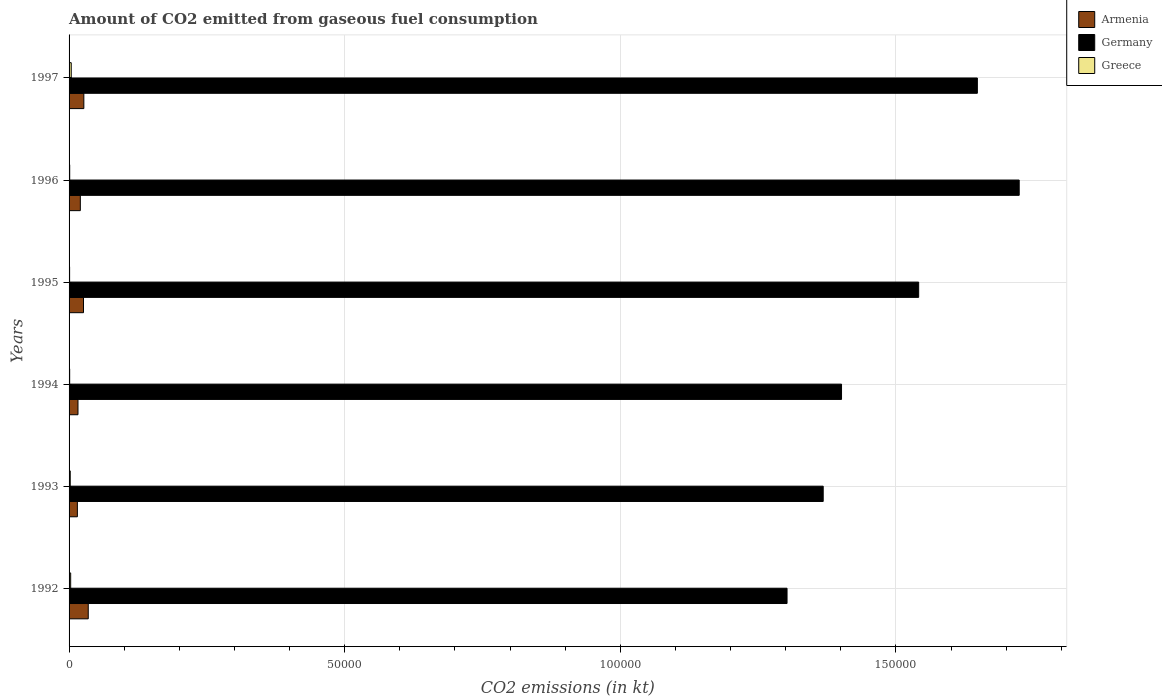How many different coloured bars are there?
Make the answer very short. 3. How many bars are there on the 3rd tick from the bottom?
Provide a succinct answer. 3. What is the label of the 4th group of bars from the top?
Keep it short and to the point. 1994. In how many cases, is the number of bars for a given year not equal to the number of legend labels?
Your answer should be very brief. 0. What is the amount of CO2 emitted in Germany in 1997?
Offer a very short reply. 1.65e+05. Across all years, what is the maximum amount of CO2 emitted in Greece?
Provide a short and direct response. 392.37. Across all years, what is the minimum amount of CO2 emitted in Greece?
Provide a short and direct response. 99.01. What is the total amount of CO2 emitted in Greece in the graph?
Make the answer very short. 1217.44. What is the difference between the amount of CO2 emitted in Greece in 1992 and that in 1996?
Your answer should be very brief. 176.02. What is the difference between the amount of CO2 emitted in Armenia in 1996 and the amount of CO2 emitted in Germany in 1995?
Keep it short and to the point. -1.52e+05. What is the average amount of CO2 emitted in Greece per year?
Offer a terse response. 202.91. In the year 1996, what is the difference between the amount of CO2 emitted in Armenia and amount of CO2 emitted in Greece?
Keep it short and to the point. 1928.84. What is the ratio of the amount of CO2 emitted in Armenia in 1992 to that in 1995?
Your response must be concise. 1.33. Is the amount of CO2 emitted in Armenia in 1993 less than that in 1996?
Your response must be concise. Yes. What is the difference between the highest and the second highest amount of CO2 emitted in Armenia?
Provide a succinct answer. 799.41. What is the difference between the highest and the lowest amount of CO2 emitted in Germany?
Your answer should be very brief. 4.21e+04. In how many years, is the amount of CO2 emitted in Greece greater than the average amount of CO2 emitted in Greece taken over all years?
Your answer should be compact. 3. Is the sum of the amount of CO2 emitted in Greece in 1995 and 1996 greater than the maximum amount of CO2 emitted in Armenia across all years?
Give a very brief answer. No. What does the 2nd bar from the bottom in 1992 represents?
Provide a short and direct response. Germany. Are all the bars in the graph horizontal?
Make the answer very short. Yes. How many years are there in the graph?
Keep it short and to the point. 6. Are the values on the major ticks of X-axis written in scientific E-notation?
Give a very brief answer. No. Where does the legend appear in the graph?
Offer a very short reply. Top right. How many legend labels are there?
Ensure brevity in your answer.  3. What is the title of the graph?
Make the answer very short. Amount of CO2 emitted from gaseous fuel consumption. Does "Nigeria" appear as one of the legend labels in the graph?
Provide a succinct answer. No. What is the label or title of the X-axis?
Ensure brevity in your answer.  CO2 emissions (in kt). What is the label or title of the Y-axis?
Keep it short and to the point. Years. What is the CO2 emissions (in kt) of Armenia in 1992?
Offer a terse response. 3479.98. What is the CO2 emissions (in kt) of Germany in 1992?
Keep it short and to the point. 1.30e+05. What is the CO2 emissions (in kt) of Greece in 1992?
Give a very brief answer. 289.69. What is the CO2 emissions (in kt) of Armenia in 1993?
Provide a short and direct response. 1507.14. What is the CO2 emissions (in kt) in Germany in 1993?
Offer a terse response. 1.37e+05. What is the CO2 emissions (in kt) of Greece in 1993?
Your response must be concise. 212.69. What is the CO2 emissions (in kt) of Armenia in 1994?
Offer a very short reply. 1617.15. What is the CO2 emissions (in kt) of Germany in 1994?
Give a very brief answer. 1.40e+05. What is the CO2 emissions (in kt) of Greece in 1994?
Your answer should be very brief. 110.01. What is the CO2 emissions (in kt) of Armenia in 1995?
Keep it short and to the point. 2618.24. What is the CO2 emissions (in kt) of Germany in 1995?
Your answer should be very brief. 1.54e+05. What is the CO2 emissions (in kt) of Greece in 1995?
Keep it short and to the point. 99.01. What is the CO2 emissions (in kt) in Armenia in 1996?
Offer a terse response. 2042.52. What is the CO2 emissions (in kt) of Germany in 1996?
Offer a terse response. 1.72e+05. What is the CO2 emissions (in kt) in Greece in 1996?
Offer a terse response. 113.68. What is the CO2 emissions (in kt) of Armenia in 1997?
Offer a terse response. 2680.58. What is the CO2 emissions (in kt) of Germany in 1997?
Give a very brief answer. 1.65e+05. What is the CO2 emissions (in kt) of Greece in 1997?
Provide a succinct answer. 392.37. Across all years, what is the maximum CO2 emissions (in kt) in Armenia?
Provide a short and direct response. 3479.98. Across all years, what is the maximum CO2 emissions (in kt) in Germany?
Offer a terse response. 1.72e+05. Across all years, what is the maximum CO2 emissions (in kt) of Greece?
Ensure brevity in your answer.  392.37. Across all years, what is the minimum CO2 emissions (in kt) of Armenia?
Give a very brief answer. 1507.14. Across all years, what is the minimum CO2 emissions (in kt) of Germany?
Provide a short and direct response. 1.30e+05. Across all years, what is the minimum CO2 emissions (in kt) of Greece?
Give a very brief answer. 99.01. What is the total CO2 emissions (in kt) of Armenia in the graph?
Make the answer very short. 1.39e+04. What is the total CO2 emissions (in kt) of Germany in the graph?
Your response must be concise. 8.99e+05. What is the total CO2 emissions (in kt) in Greece in the graph?
Your answer should be compact. 1217.44. What is the difference between the CO2 emissions (in kt) of Armenia in 1992 and that in 1993?
Ensure brevity in your answer.  1972.85. What is the difference between the CO2 emissions (in kt) of Germany in 1992 and that in 1993?
Make the answer very short. -6560.26. What is the difference between the CO2 emissions (in kt) in Greece in 1992 and that in 1993?
Keep it short and to the point. 77.01. What is the difference between the CO2 emissions (in kt) in Armenia in 1992 and that in 1994?
Keep it short and to the point. 1862.84. What is the difference between the CO2 emissions (in kt) in Germany in 1992 and that in 1994?
Make the answer very short. -9886.23. What is the difference between the CO2 emissions (in kt) of Greece in 1992 and that in 1994?
Provide a short and direct response. 179.68. What is the difference between the CO2 emissions (in kt) of Armenia in 1992 and that in 1995?
Your answer should be compact. 861.75. What is the difference between the CO2 emissions (in kt) of Germany in 1992 and that in 1995?
Keep it short and to the point. -2.39e+04. What is the difference between the CO2 emissions (in kt) of Greece in 1992 and that in 1995?
Ensure brevity in your answer.  190.68. What is the difference between the CO2 emissions (in kt) in Armenia in 1992 and that in 1996?
Offer a terse response. 1437.46. What is the difference between the CO2 emissions (in kt) of Germany in 1992 and that in 1996?
Your answer should be very brief. -4.21e+04. What is the difference between the CO2 emissions (in kt) of Greece in 1992 and that in 1996?
Offer a very short reply. 176.02. What is the difference between the CO2 emissions (in kt) in Armenia in 1992 and that in 1997?
Make the answer very short. 799.41. What is the difference between the CO2 emissions (in kt) in Germany in 1992 and that in 1997?
Keep it short and to the point. -3.45e+04. What is the difference between the CO2 emissions (in kt) of Greece in 1992 and that in 1997?
Your answer should be compact. -102.68. What is the difference between the CO2 emissions (in kt) in Armenia in 1993 and that in 1994?
Your answer should be very brief. -110.01. What is the difference between the CO2 emissions (in kt) of Germany in 1993 and that in 1994?
Offer a terse response. -3325.97. What is the difference between the CO2 emissions (in kt) in Greece in 1993 and that in 1994?
Your answer should be very brief. 102.68. What is the difference between the CO2 emissions (in kt) of Armenia in 1993 and that in 1995?
Ensure brevity in your answer.  -1111.1. What is the difference between the CO2 emissions (in kt) of Germany in 1993 and that in 1995?
Give a very brief answer. -1.73e+04. What is the difference between the CO2 emissions (in kt) in Greece in 1993 and that in 1995?
Make the answer very short. 113.68. What is the difference between the CO2 emissions (in kt) in Armenia in 1993 and that in 1996?
Your answer should be compact. -535.38. What is the difference between the CO2 emissions (in kt) of Germany in 1993 and that in 1996?
Your answer should be compact. -3.56e+04. What is the difference between the CO2 emissions (in kt) of Greece in 1993 and that in 1996?
Provide a succinct answer. 99.01. What is the difference between the CO2 emissions (in kt) of Armenia in 1993 and that in 1997?
Provide a succinct answer. -1173.44. What is the difference between the CO2 emissions (in kt) in Germany in 1993 and that in 1997?
Give a very brief answer. -2.80e+04. What is the difference between the CO2 emissions (in kt) of Greece in 1993 and that in 1997?
Give a very brief answer. -179.68. What is the difference between the CO2 emissions (in kt) of Armenia in 1994 and that in 1995?
Your answer should be very brief. -1001.09. What is the difference between the CO2 emissions (in kt) in Germany in 1994 and that in 1995?
Ensure brevity in your answer.  -1.40e+04. What is the difference between the CO2 emissions (in kt) of Greece in 1994 and that in 1995?
Provide a succinct answer. 11. What is the difference between the CO2 emissions (in kt) in Armenia in 1994 and that in 1996?
Provide a short and direct response. -425.37. What is the difference between the CO2 emissions (in kt) of Germany in 1994 and that in 1996?
Give a very brief answer. -3.22e+04. What is the difference between the CO2 emissions (in kt) in Greece in 1994 and that in 1996?
Provide a short and direct response. -3.67. What is the difference between the CO2 emissions (in kt) of Armenia in 1994 and that in 1997?
Offer a terse response. -1063.43. What is the difference between the CO2 emissions (in kt) of Germany in 1994 and that in 1997?
Ensure brevity in your answer.  -2.46e+04. What is the difference between the CO2 emissions (in kt) of Greece in 1994 and that in 1997?
Provide a succinct answer. -282.36. What is the difference between the CO2 emissions (in kt) in Armenia in 1995 and that in 1996?
Offer a very short reply. 575.72. What is the difference between the CO2 emissions (in kt) of Germany in 1995 and that in 1996?
Keep it short and to the point. -1.82e+04. What is the difference between the CO2 emissions (in kt) in Greece in 1995 and that in 1996?
Ensure brevity in your answer.  -14.67. What is the difference between the CO2 emissions (in kt) of Armenia in 1995 and that in 1997?
Ensure brevity in your answer.  -62.34. What is the difference between the CO2 emissions (in kt) in Germany in 1995 and that in 1997?
Provide a short and direct response. -1.06e+04. What is the difference between the CO2 emissions (in kt) in Greece in 1995 and that in 1997?
Offer a very short reply. -293.36. What is the difference between the CO2 emissions (in kt) of Armenia in 1996 and that in 1997?
Provide a short and direct response. -638.06. What is the difference between the CO2 emissions (in kt) in Germany in 1996 and that in 1997?
Offer a very short reply. 7590.69. What is the difference between the CO2 emissions (in kt) in Greece in 1996 and that in 1997?
Your response must be concise. -278.69. What is the difference between the CO2 emissions (in kt) of Armenia in 1992 and the CO2 emissions (in kt) of Germany in 1993?
Your answer should be very brief. -1.33e+05. What is the difference between the CO2 emissions (in kt) of Armenia in 1992 and the CO2 emissions (in kt) of Greece in 1993?
Provide a short and direct response. 3267.3. What is the difference between the CO2 emissions (in kt) in Germany in 1992 and the CO2 emissions (in kt) in Greece in 1993?
Offer a terse response. 1.30e+05. What is the difference between the CO2 emissions (in kt) in Armenia in 1992 and the CO2 emissions (in kt) in Germany in 1994?
Offer a terse response. -1.37e+05. What is the difference between the CO2 emissions (in kt) in Armenia in 1992 and the CO2 emissions (in kt) in Greece in 1994?
Offer a terse response. 3369.97. What is the difference between the CO2 emissions (in kt) of Germany in 1992 and the CO2 emissions (in kt) of Greece in 1994?
Your response must be concise. 1.30e+05. What is the difference between the CO2 emissions (in kt) of Armenia in 1992 and the CO2 emissions (in kt) of Germany in 1995?
Give a very brief answer. -1.51e+05. What is the difference between the CO2 emissions (in kt) in Armenia in 1992 and the CO2 emissions (in kt) in Greece in 1995?
Your response must be concise. 3380.97. What is the difference between the CO2 emissions (in kt) in Germany in 1992 and the CO2 emissions (in kt) in Greece in 1995?
Offer a very short reply. 1.30e+05. What is the difference between the CO2 emissions (in kt) in Armenia in 1992 and the CO2 emissions (in kt) in Germany in 1996?
Keep it short and to the point. -1.69e+05. What is the difference between the CO2 emissions (in kt) in Armenia in 1992 and the CO2 emissions (in kt) in Greece in 1996?
Make the answer very short. 3366.31. What is the difference between the CO2 emissions (in kt) of Germany in 1992 and the CO2 emissions (in kt) of Greece in 1996?
Offer a terse response. 1.30e+05. What is the difference between the CO2 emissions (in kt) of Armenia in 1992 and the CO2 emissions (in kt) of Germany in 1997?
Give a very brief answer. -1.61e+05. What is the difference between the CO2 emissions (in kt) of Armenia in 1992 and the CO2 emissions (in kt) of Greece in 1997?
Keep it short and to the point. 3087.61. What is the difference between the CO2 emissions (in kt) in Germany in 1992 and the CO2 emissions (in kt) in Greece in 1997?
Ensure brevity in your answer.  1.30e+05. What is the difference between the CO2 emissions (in kt) of Armenia in 1993 and the CO2 emissions (in kt) of Germany in 1994?
Your answer should be very brief. -1.39e+05. What is the difference between the CO2 emissions (in kt) of Armenia in 1993 and the CO2 emissions (in kt) of Greece in 1994?
Your answer should be very brief. 1397.13. What is the difference between the CO2 emissions (in kt) of Germany in 1993 and the CO2 emissions (in kt) of Greece in 1994?
Provide a short and direct response. 1.37e+05. What is the difference between the CO2 emissions (in kt) of Armenia in 1993 and the CO2 emissions (in kt) of Germany in 1995?
Offer a very short reply. -1.53e+05. What is the difference between the CO2 emissions (in kt) in Armenia in 1993 and the CO2 emissions (in kt) in Greece in 1995?
Your answer should be very brief. 1408.13. What is the difference between the CO2 emissions (in kt) in Germany in 1993 and the CO2 emissions (in kt) in Greece in 1995?
Your answer should be compact. 1.37e+05. What is the difference between the CO2 emissions (in kt) in Armenia in 1993 and the CO2 emissions (in kt) in Germany in 1996?
Ensure brevity in your answer.  -1.71e+05. What is the difference between the CO2 emissions (in kt) in Armenia in 1993 and the CO2 emissions (in kt) in Greece in 1996?
Your answer should be compact. 1393.46. What is the difference between the CO2 emissions (in kt) in Germany in 1993 and the CO2 emissions (in kt) in Greece in 1996?
Offer a very short reply. 1.37e+05. What is the difference between the CO2 emissions (in kt) in Armenia in 1993 and the CO2 emissions (in kt) in Germany in 1997?
Offer a terse response. -1.63e+05. What is the difference between the CO2 emissions (in kt) in Armenia in 1993 and the CO2 emissions (in kt) in Greece in 1997?
Make the answer very short. 1114.77. What is the difference between the CO2 emissions (in kt) of Germany in 1993 and the CO2 emissions (in kt) of Greece in 1997?
Offer a terse response. 1.36e+05. What is the difference between the CO2 emissions (in kt) of Armenia in 1994 and the CO2 emissions (in kt) of Germany in 1995?
Make the answer very short. -1.53e+05. What is the difference between the CO2 emissions (in kt) of Armenia in 1994 and the CO2 emissions (in kt) of Greece in 1995?
Offer a terse response. 1518.14. What is the difference between the CO2 emissions (in kt) in Germany in 1994 and the CO2 emissions (in kt) in Greece in 1995?
Your answer should be very brief. 1.40e+05. What is the difference between the CO2 emissions (in kt) of Armenia in 1994 and the CO2 emissions (in kt) of Germany in 1996?
Your answer should be compact. -1.71e+05. What is the difference between the CO2 emissions (in kt) in Armenia in 1994 and the CO2 emissions (in kt) in Greece in 1996?
Your answer should be compact. 1503.47. What is the difference between the CO2 emissions (in kt) in Germany in 1994 and the CO2 emissions (in kt) in Greece in 1996?
Offer a very short reply. 1.40e+05. What is the difference between the CO2 emissions (in kt) of Armenia in 1994 and the CO2 emissions (in kt) of Germany in 1997?
Provide a succinct answer. -1.63e+05. What is the difference between the CO2 emissions (in kt) of Armenia in 1994 and the CO2 emissions (in kt) of Greece in 1997?
Provide a short and direct response. 1224.78. What is the difference between the CO2 emissions (in kt) of Germany in 1994 and the CO2 emissions (in kt) of Greece in 1997?
Your answer should be compact. 1.40e+05. What is the difference between the CO2 emissions (in kt) of Armenia in 1995 and the CO2 emissions (in kt) of Germany in 1996?
Your answer should be very brief. -1.70e+05. What is the difference between the CO2 emissions (in kt) of Armenia in 1995 and the CO2 emissions (in kt) of Greece in 1996?
Give a very brief answer. 2504.56. What is the difference between the CO2 emissions (in kt) of Germany in 1995 and the CO2 emissions (in kt) of Greece in 1996?
Your answer should be compact. 1.54e+05. What is the difference between the CO2 emissions (in kt) of Armenia in 1995 and the CO2 emissions (in kt) of Germany in 1997?
Your answer should be very brief. -1.62e+05. What is the difference between the CO2 emissions (in kt) of Armenia in 1995 and the CO2 emissions (in kt) of Greece in 1997?
Ensure brevity in your answer.  2225.87. What is the difference between the CO2 emissions (in kt) in Germany in 1995 and the CO2 emissions (in kt) in Greece in 1997?
Provide a succinct answer. 1.54e+05. What is the difference between the CO2 emissions (in kt) of Armenia in 1996 and the CO2 emissions (in kt) of Germany in 1997?
Your answer should be compact. -1.63e+05. What is the difference between the CO2 emissions (in kt) in Armenia in 1996 and the CO2 emissions (in kt) in Greece in 1997?
Give a very brief answer. 1650.15. What is the difference between the CO2 emissions (in kt) of Germany in 1996 and the CO2 emissions (in kt) of Greece in 1997?
Offer a very short reply. 1.72e+05. What is the average CO2 emissions (in kt) in Armenia per year?
Provide a succinct answer. 2324.27. What is the average CO2 emissions (in kt) of Germany per year?
Your answer should be compact. 1.50e+05. What is the average CO2 emissions (in kt) in Greece per year?
Your response must be concise. 202.91. In the year 1992, what is the difference between the CO2 emissions (in kt) of Armenia and CO2 emissions (in kt) of Germany?
Your answer should be compact. -1.27e+05. In the year 1992, what is the difference between the CO2 emissions (in kt) in Armenia and CO2 emissions (in kt) in Greece?
Provide a succinct answer. 3190.29. In the year 1992, what is the difference between the CO2 emissions (in kt) in Germany and CO2 emissions (in kt) in Greece?
Offer a very short reply. 1.30e+05. In the year 1993, what is the difference between the CO2 emissions (in kt) of Armenia and CO2 emissions (in kt) of Germany?
Provide a short and direct response. -1.35e+05. In the year 1993, what is the difference between the CO2 emissions (in kt) in Armenia and CO2 emissions (in kt) in Greece?
Your answer should be compact. 1294.45. In the year 1993, what is the difference between the CO2 emissions (in kt) of Germany and CO2 emissions (in kt) of Greece?
Ensure brevity in your answer.  1.37e+05. In the year 1994, what is the difference between the CO2 emissions (in kt) of Armenia and CO2 emissions (in kt) of Germany?
Your response must be concise. -1.39e+05. In the year 1994, what is the difference between the CO2 emissions (in kt) of Armenia and CO2 emissions (in kt) of Greece?
Ensure brevity in your answer.  1507.14. In the year 1994, what is the difference between the CO2 emissions (in kt) in Germany and CO2 emissions (in kt) in Greece?
Keep it short and to the point. 1.40e+05. In the year 1995, what is the difference between the CO2 emissions (in kt) of Armenia and CO2 emissions (in kt) of Germany?
Offer a very short reply. -1.52e+05. In the year 1995, what is the difference between the CO2 emissions (in kt) in Armenia and CO2 emissions (in kt) in Greece?
Give a very brief answer. 2519.23. In the year 1995, what is the difference between the CO2 emissions (in kt) of Germany and CO2 emissions (in kt) of Greece?
Your response must be concise. 1.54e+05. In the year 1996, what is the difference between the CO2 emissions (in kt) in Armenia and CO2 emissions (in kt) in Germany?
Your response must be concise. -1.70e+05. In the year 1996, what is the difference between the CO2 emissions (in kt) of Armenia and CO2 emissions (in kt) of Greece?
Keep it short and to the point. 1928.84. In the year 1996, what is the difference between the CO2 emissions (in kt) in Germany and CO2 emissions (in kt) in Greece?
Your answer should be compact. 1.72e+05. In the year 1997, what is the difference between the CO2 emissions (in kt) in Armenia and CO2 emissions (in kt) in Germany?
Give a very brief answer. -1.62e+05. In the year 1997, what is the difference between the CO2 emissions (in kt) of Armenia and CO2 emissions (in kt) of Greece?
Offer a very short reply. 2288.21. In the year 1997, what is the difference between the CO2 emissions (in kt) of Germany and CO2 emissions (in kt) of Greece?
Your response must be concise. 1.64e+05. What is the ratio of the CO2 emissions (in kt) of Armenia in 1992 to that in 1993?
Make the answer very short. 2.31. What is the ratio of the CO2 emissions (in kt) in Germany in 1992 to that in 1993?
Give a very brief answer. 0.95. What is the ratio of the CO2 emissions (in kt) of Greece in 1992 to that in 1993?
Ensure brevity in your answer.  1.36. What is the ratio of the CO2 emissions (in kt) in Armenia in 1992 to that in 1994?
Ensure brevity in your answer.  2.15. What is the ratio of the CO2 emissions (in kt) of Germany in 1992 to that in 1994?
Provide a succinct answer. 0.93. What is the ratio of the CO2 emissions (in kt) in Greece in 1992 to that in 1994?
Offer a terse response. 2.63. What is the ratio of the CO2 emissions (in kt) of Armenia in 1992 to that in 1995?
Your answer should be compact. 1.33. What is the ratio of the CO2 emissions (in kt) in Germany in 1992 to that in 1995?
Your answer should be compact. 0.85. What is the ratio of the CO2 emissions (in kt) in Greece in 1992 to that in 1995?
Offer a terse response. 2.93. What is the ratio of the CO2 emissions (in kt) of Armenia in 1992 to that in 1996?
Offer a very short reply. 1.7. What is the ratio of the CO2 emissions (in kt) in Germany in 1992 to that in 1996?
Offer a terse response. 0.76. What is the ratio of the CO2 emissions (in kt) in Greece in 1992 to that in 1996?
Make the answer very short. 2.55. What is the ratio of the CO2 emissions (in kt) in Armenia in 1992 to that in 1997?
Make the answer very short. 1.3. What is the ratio of the CO2 emissions (in kt) of Germany in 1992 to that in 1997?
Give a very brief answer. 0.79. What is the ratio of the CO2 emissions (in kt) in Greece in 1992 to that in 1997?
Give a very brief answer. 0.74. What is the ratio of the CO2 emissions (in kt) in Armenia in 1993 to that in 1994?
Your answer should be compact. 0.93. What is the ratio of the CO2 emissions (in kt) in Germany in 1993 to that in 1994?
Give a very brief answer. 0.98. What is the ratio of the CO2 emissions (in kt) of Greece in 1993 to that in 1994?
Give a very brief answer. 1.93. What is the ratio of the CO2 emissions (in kt) of Armenia in 1993 to that in 1995?
Your answer should be very brief. 0.58. What is the ratio of the CO2 emissions (in kt) in Germany in 1993 to that in 1995?
Ensure brevity in your answer.  0.89. What is the ratio of the CO2 emissions (in kt) of Greece in 1993 to that in 1995?
Provide a succinct answer. 2.15. What is the ratio of the CO2 emissions (in kt) in Armenia in 1993 to that in 1996?
Keep it short and to the point. 0.74. What is the ratio of the CO2 emissions (in kt) of Germany in 1993 to that in 1996?
Give a very brief answer. 0.79. What is the ratio of the CO2 emissions (in kt) of Greece in 1993 to that in 1996?
Provide a succinct answer. 1.87. What is the ratio of the CO2 emissions (in kt) of Armenia in 1993 to that in 1997?
Your answer should be very brief. 0.56. What is the ratio of the CO2 emissions (in kt) in Germany in 1993 to that in 1997?
Offer a terse response. 0.83. What is the ratio of the CO2 emissions (in kt) in Greece in 1993 to that in 1997?
Give a very brief answer. 0.54. What is the ratio of the CO2 emissions (in kt) of Armenia in 1994 to that in 1995?
Make the answer very short. 0.62. What is the ratio of the CO2 emissions (in kt) in Germany in 1994 to that in 1995?
Provide a short and direct response. 0.91. What is the ratio of the CO2 emissions (in kt) of Greece in 1994 to that in 1995?
Your answer should be compact. 1.11. What is the ratio of the CO2 emissions (in kt) in Armenia in 1994 to that in 1996?
Provide a succinct answer. 0.79. What is the ratio of the CO2 emissions (in kt) of Germany in 1994 to that in 1996?
Provide a succinct answer. 0.81. What is the ratio of the CO2 emissions (in kt) in Greece in 1994 to that in 1996?
Your answer should be very brief. 0.97. What is the ratio of the CO2 emissions (in kt) of Armenia in 1994 to that in 1997?
Provide a succinct answer. 0.6. What is the ratio of the CO2 emissions (in kt) of Germany in 1994 to that in 1997?
Ensure brevity in your answer.  0.85. What is the ratio of the CO2 emissions (in kt) of Greece in 1994 to that in 1997?
Give a very brief answer. 0.28. What is the ratio of the CO2 emissions (in kt) of Armenia in 1995 to that in 1996?
Make the answer very short. 1.28. What is the ratio of the CO2 emissions (in kt) in Germany in 1995 to that in 1996?
Keep it short and to the point. 0.89. What is the ratio of the CO2 emissions (in kt) of Greece in 1995 to that in 1996?
Offer a very short reply. 0.87. What is the ratio of the CO2 emissions (in kt) of Armenia in 1995 to that in 1997?
Provide a succinct answer. 0.98. What is the ratio of the CO2 emissions (in kt) of Germany in 1995 to that in 1997?
Make the answer very short. 0.94. What is the ratio of the CO2 emissions (in kt) in Greece in 1995 to that in 1997?
Your answer should be compact. 0.25. What is the ratio of the CO2 emissions (in kt) of Armenia in 1996 to that in 1997?
Give a very brief answer. 0.76. What is the ratio of the CO2 emissions (in kt) of Germany in 1996 to that in 1997?
Offer a terse response. 1.05. What is the ratio of the CO2 emissions (in kt) in Greece in 1996 to that in 1997?
Provide a succinct answer. 0.29. What is the difference between the highest and the second highest CO2 emissions (in kt) of Armenia?
Make the answer very short. 799.41. What is the difference between the highest and the second highest CO2 emissions (in kt) in Germany?
Provide a succinct answer. 7590.69. What is the difference between the highest and the second highest CO2 emissions (in kt) of Greece?
Provide a succinct answer. 102.68. What is the difference between the highest and the lowest CO2 emissions (in kt) in Armenia?
Make the answer very short. 1972.85. What is the difference between the highest and the lowest CO2 emissions (in kt) of Germany?
Provide a succinct answer. 4.21e+04. What is the difference between the highest and the lowest CO2 emissions (in kt) in Greece?
Offer a very short reply. 293.36. 